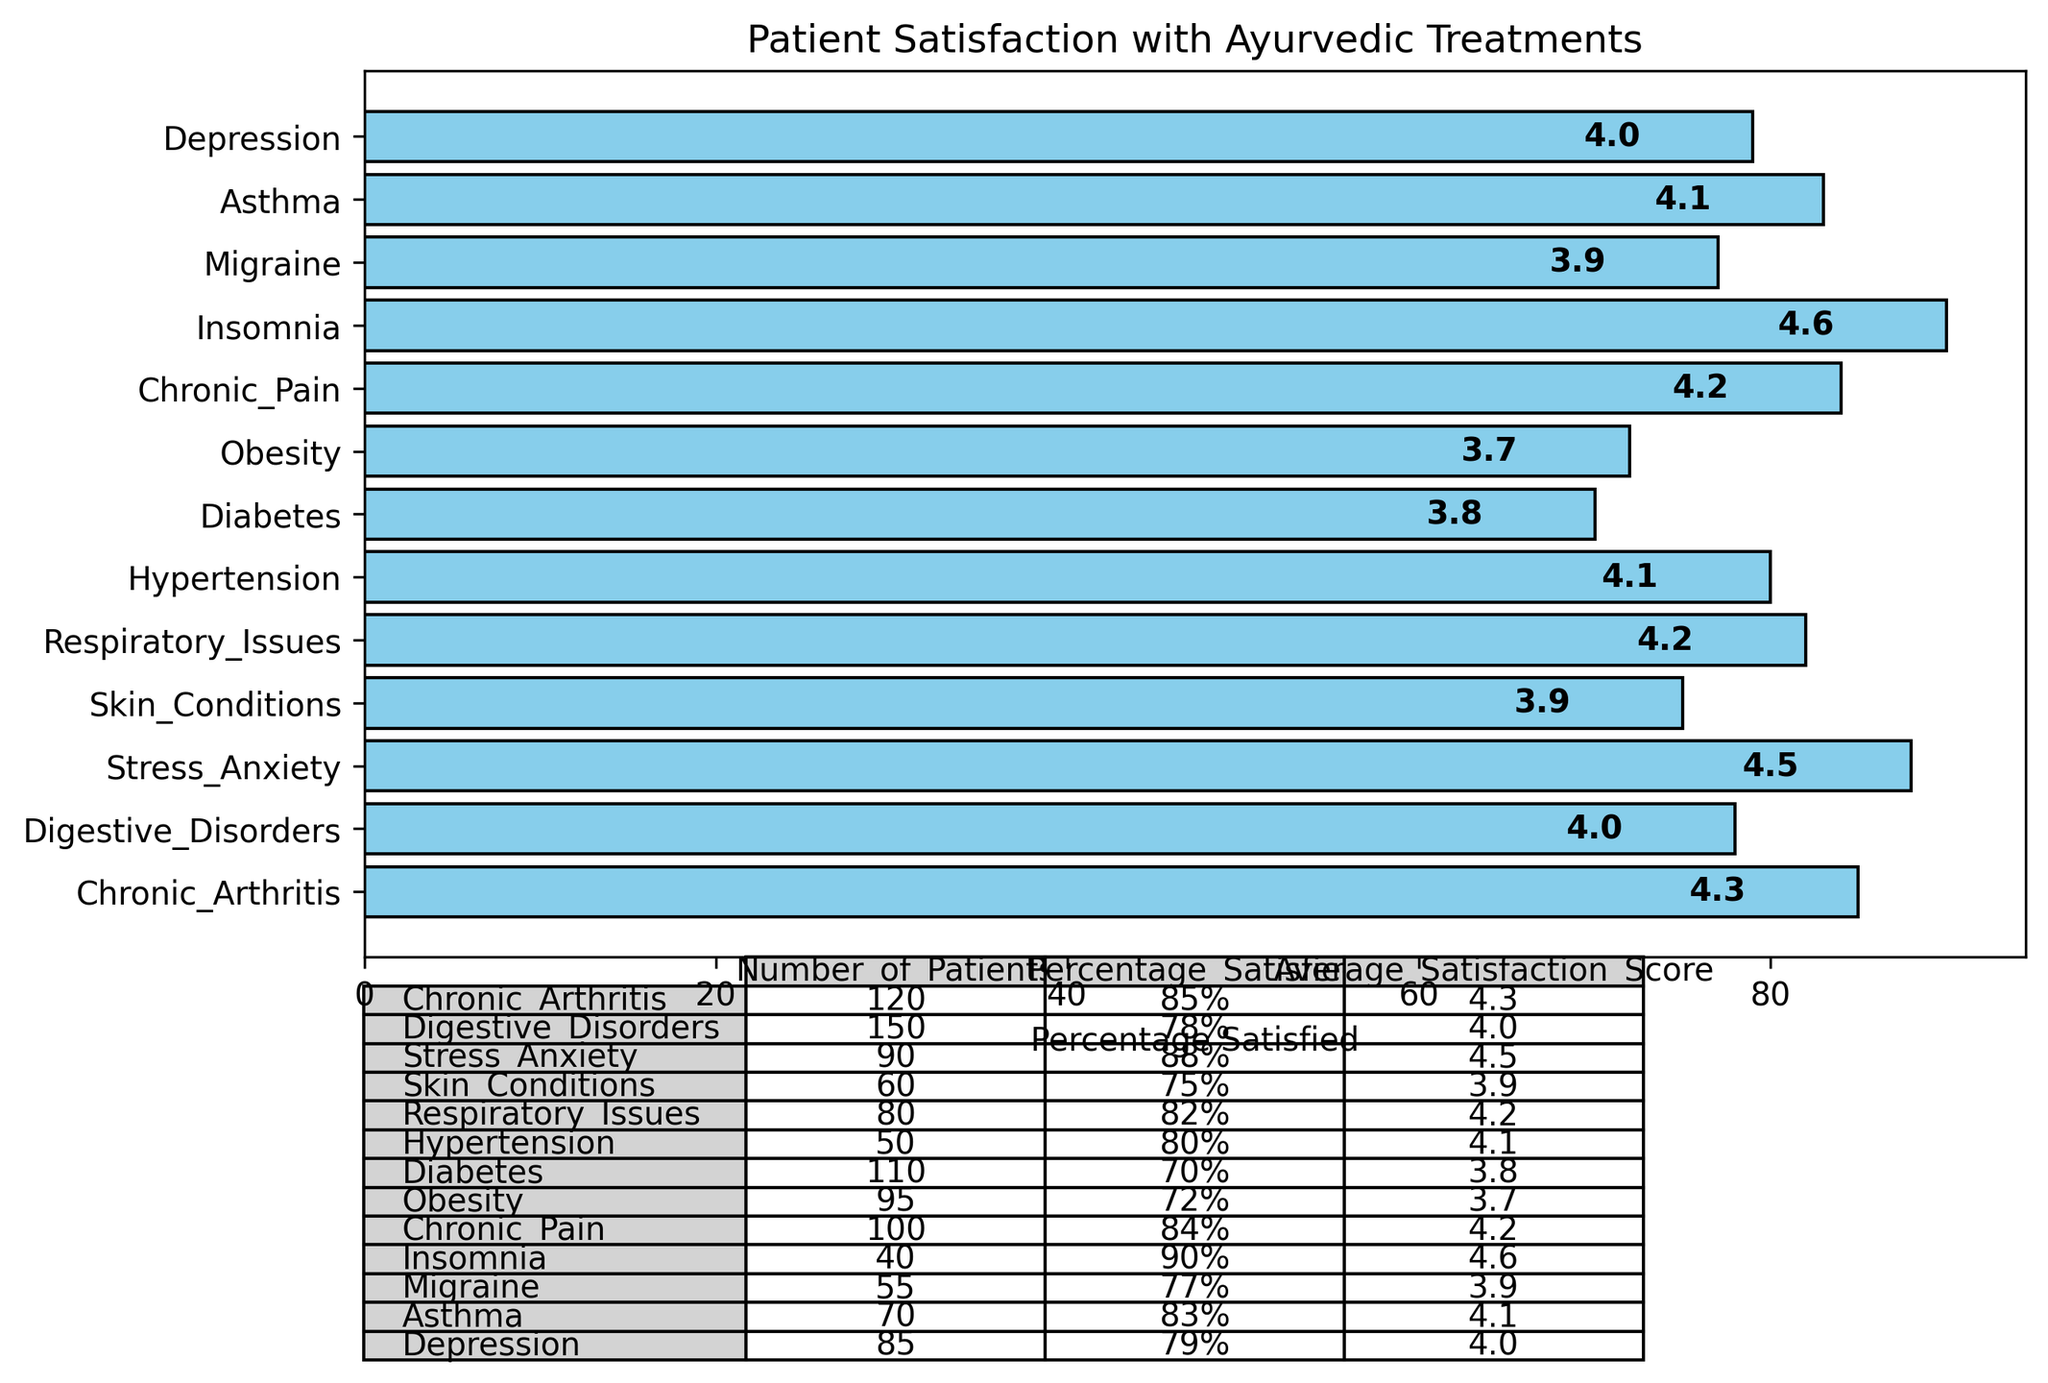Which condition has the highest Average Satisfaction Score? By identifying the conditional labels and comparing the values, we find that Insomnia has the highest Average Satisfaction Score of 4.6.
Answer: Insomnia What is the average Percentage Satisfied across Chronic Arthritis, Digestive Disorders, and Stress/Anxiety? First, sum the percentages: 85 (Chronic Arthritis) + 78 (Digestive Disorders) + 88 (Stress/Anxiety) = 251. Then, divide by the number of conditions: 251 / 3 = 83.67.
Answer: 83.67% Which condition has the lowest Percentage Satisfied? By comparing the percentages of all conditions, we see that Diabetes has the lowest Percentage Satisfied of 70%.
Answer: Diabetes How does the Percentage Satisfied for Obesity compare to that for Skin Conditions? The Percentage Satisfied for Obesity is 72%, while for Skin Conditions it is 75%. Therefore, the Percentage Satisfied for Skin Conditions is higher than for Obesity.
Answer: Skin Conditions is higher Which two conditions have Percentage Satisfied of at least 90%? By checking the percentages, Insomnia (90%) and Stress/Anxiety (88%) are closest to 90%, but Insomnia is exactly 90%. After evaluating all, Insomnia is unique with at least 90%.
Answer: Only Insomnia What is the total number of patients for Chronic Pain and Hypertension combined? Summing the number of patients for Chronic Pain (100) and Hypertension (50) gives 100 + 50 = 150.
Answer: 150 Between Asthma and Migraine, which condition has a higher Average Satisfaction Score? Comparing the values, Asthma has an Average Satisfaction Score of 4.1, while Migraine has a score of 3.9. Thus, Asthma has a higher score.
Answer: Asthma What is the median Percentage Satisfied for all conditions? Sorting the percentages: 70, 72, 75, 77, 78, 79, 80, 82, 83, 84, 85, 88, 90, the median is the middle value, which is 80 (Hypertension).
Answer: 80% How many conditions have an Average Satisfaction Score above 4.0? Count the conditions with Average Satisfaction Scores greater than 4.0 (Chronic Arthritis, Stress/Anxiety, Respiratory Issues, Hypertension, Chronic Pain, Asthma, Insomnia), which totals to 7.
Answer: 7 Which condition has the largest number of patients and what is its Average Satisfaction Score? Digestive Disorders has the largest number of patients (150) and its Average Satisfaction Score is 4.0.
Answer: Digestive Disorders, 4.0 